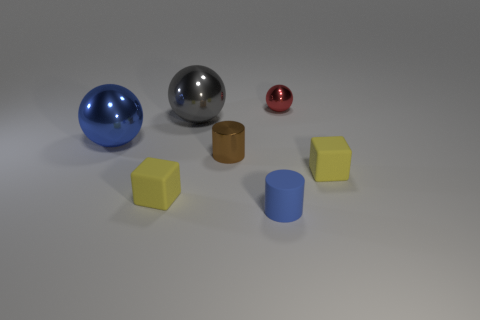Are there any other things that are the same material as the small blue cylinder?
Keep it short and to the point. Yes. What is the color of the metal cylinder?
Give a very brief answer. Brown. What is the shape of the big thing that is the same color as the rubber cylinder?
Provide a succinct answer. Sphere. There is another metal object that is the same size as the gray thing; what is its color?
Keep it short and to the point. Blue. What number of rubber objects are either large blue cylinders or large blue balls?
Ensure brevity in your answer.  0. What number of balls are on the left side of the shiny cylinder and on the right side of the rubber cylinder?
Make the answer very short. 0. What number of other objects are there of the same size as the blue rubber cylinder?
Your response must be concise. 4. There is a rubber block that is to the left of the small red metallic ball; is it the same size as the matte thing that is to the right of the tiny sphere?
Offer a terse response. Yes. How many things are large shiny objects or small yellow matte objects left of the red metal thing?
Your answer should be compact. 3. How big is the blue object that is to the left of the blue cylinder?
Provide a short and direct response. Large. 